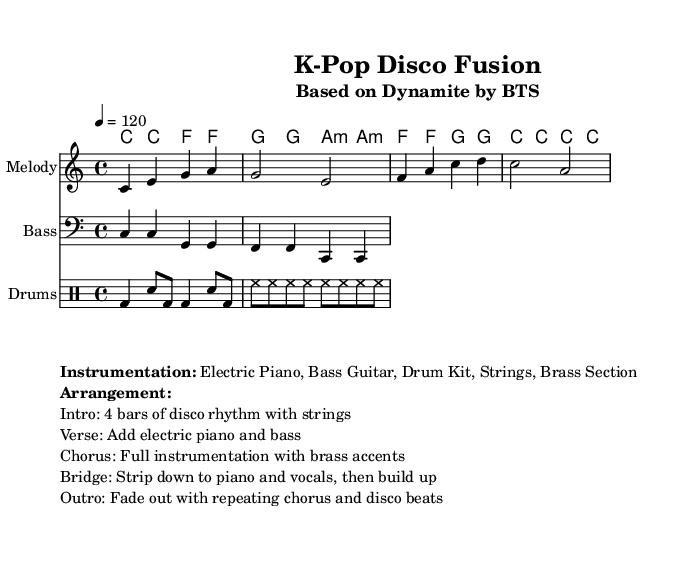What is the key signature of this music? The key signature is C major, which is indicated by no sharps or flats at the beginning of the staff.
Answer: C major What is the time signature used in this piece? The time signature is 4/4, which is displayed at the beginning of the score, indicating four beats in a measure.
Answer: 4/4 What is the tempo marking given for this music? The tempo marking is given as 4 = 120, which means there should be 120 quarter note beats per minute.
Answer: 120 How many measures are in the provided melody? The melody section has 8 measures, as indicated by the number of distinct groups of notes separated by the vertical bar lines.
Answer: 8 Which instrument is playing the bass line? The bass line is performed by the Bass guitar, which is indicated by the clef and notation for low notes in the staff.
Answer: Bass guitar What instrumentation is used in this arrangement? The score specifies Electric Piano, Bass Guitar, Drum Kit, Strings, and Brass Section, as noted in the markup section that details the instrumentation.
Answer: Electric Piano, Bass Guitar, Drum Kit, Strings, Brass Section What type of rhythmic feel does this piece communicate? This piece communicates a disco rhythmic feel, as indicated by the drum patterns and the overall arrangement typical of disco music genres that emphasize danceable beats.
Answer: Disco 